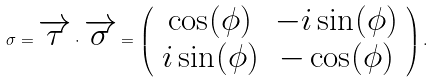Convert formula to latex. <formula><loc_0><loc_0><loc_500><loc_500>\sigma = \overrightarrow { \tau } \cdot \overrightarrow { \sigma } = \left ( \begin{array} { c c } \cos ( \phi ) & - i \sin ( \phi ) \\ i \sin ( \phi ) & - \cos ( \phi ) \end{array} \right ) .</formula> 